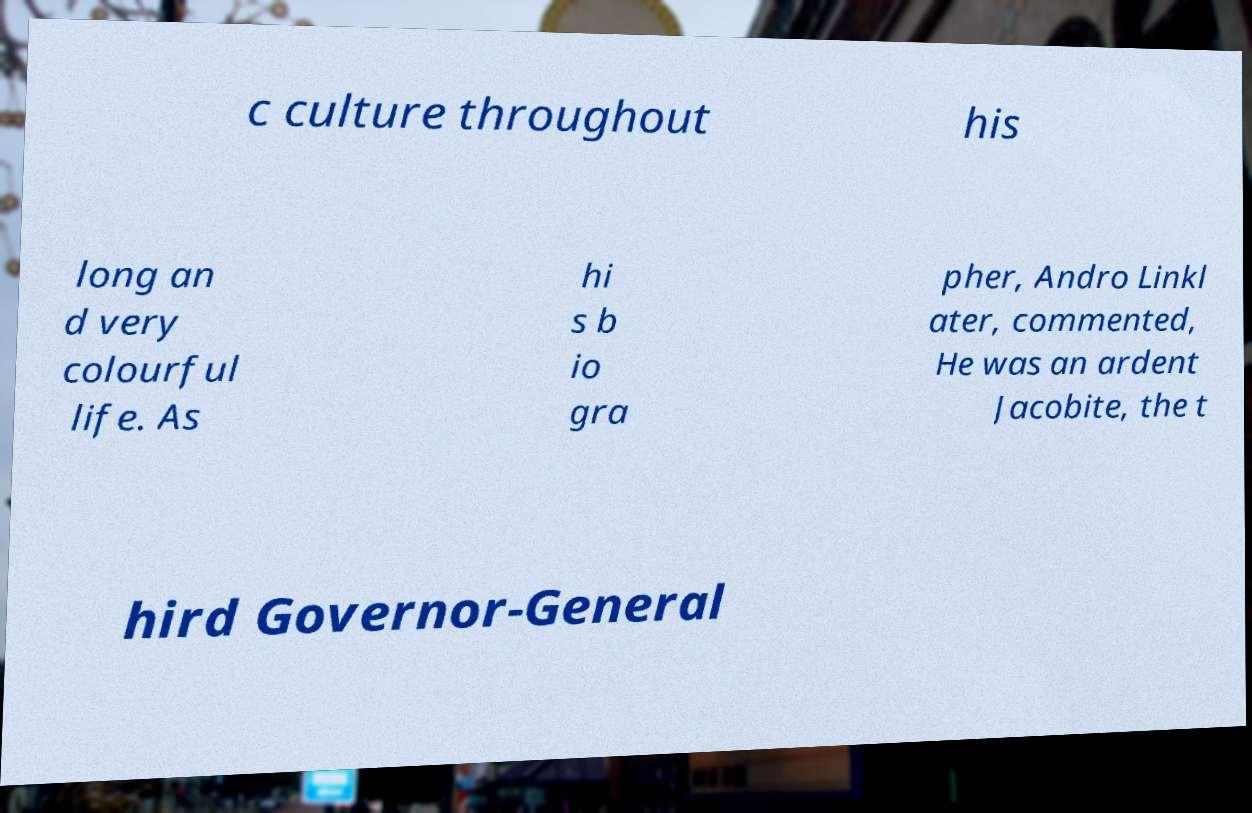Could you extract and type out the text from this image? c culture throughout his long an d very colourful life. As hi s b io gra pher, Andro Linkl ater, commented, He was an ardent Jacobite, the t hird Governor-General 